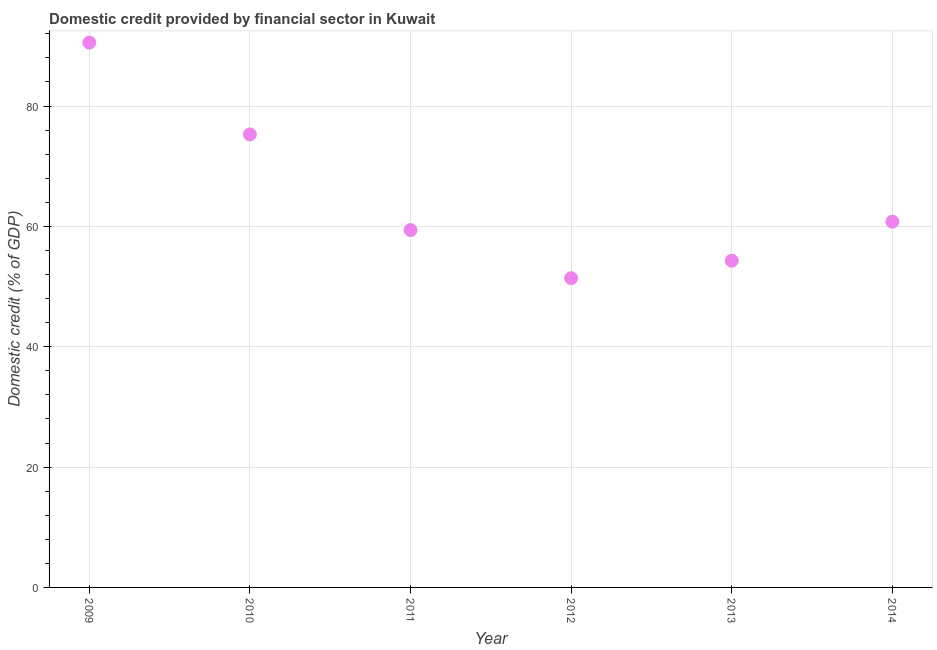What is the domestic credit provided by financial sector in 2011?
Your answer should be compact. 59.39. Across all years, what is the maximum domestic credit provided by financial sector?
Your answer should be very brief. 90.54. Across all years, what is the minimum domestic credit provided by financial sector?
Give a very brief answer. 51.39. In which year was the domestic credit provided by financial sector minimum?
Make the answer very short. 2012. What is the sum of the domestic credit provided by financial sector?
Offer a very short reply. 391.68. What is the difference between the domestic credit provided by financial sector in 2010 and 2014?
Provide a short and direct response. 14.51. What is the average domestic credit provided by financial sector per year?
Provide a short and direct response. 65.28. What is the median domestic credit provided by financial sector?
Offer a terse response. 60.08. Do a majority of the years between 2012 and 2014 (inclusive) have domestic credit provided by financial sector greater than 24 %?
Your answer should be very brief. Yes. What is the ratio of the domestic credit provided by financial sector in 2009 to that in 2013?
Your answer should be compact. 1.67. Is the domestic credit provided by financial sector in 2011 less than that in 2012?
Your answer should be very brief. No. What is the difference between the highest and the second highest domestic credit provided by financial sector?
Offer a terse response. 15.26. Is the sum of the domestic credit provided by financial sector in 2010 and 2014 greater than the maximum domestic credit provided by financial sector across all years?
Keep it short and to the point. Yes. What is the difference between the highest and the lowest domestic credit provided by financial sector?
Make the answer very short. 39.15. In how many years, is the domestic credit provided by financial sector greater than the average domestic credit provided by financial sector taken over all years?
Ensure brevity in your answer.  2. How many dotlines are there?
Make the answer very short. 1. How many years are there in the graph?
Your response must be concise. 6. What is the difference between two consecutive major ticks on the Y-axis?
Make the answer very short. 20. Are the values on the major ticks of Y-axis written in scientific E-notation?
Provide a succinct answer. No. What is the title of the graph?
Offer a very short reply. Domestic credit provided by financial sector in Kuwait. What is the label or title of the Y-axis?
Provide a succinct answer. Domestic credit (% of GDP). What is the Domestic credit (% of GDP) in 2009?
Offer a very short reply. 90.54. What is the Domestic credit (% of GDP) in 2010?
Give a very brief answer. 75.28. What is the Domestic credit (% of GDP) in 2011?
Your response must be concise. 59.39. What is the Domestic credit (% of GDP) in 2012?
Keep it short and to the point. 51.39. What is the Domestic credit (% of GDP) in 2013?
Offer a terse response. 54.3. What is the Domestic credit (% of GDP) in 2014?
Your answer should be very brief. 60.78. What is the difference between the Domestic credit (% of GDP) in 2009 and 2010?
Provide a succinct answer. 15.26. What is the difference between the Domestic credit (% of GDP) in 2009 and 2011?
Give a very brief answer. 31.15. What is the difference between the Domestic credit (% of GDP) in 2009 and 2012?
Keep it short and to the point. 39.15. What is the difference between the Domestic credit (% of GDP) in 2009 and 2013?
Offer a very short reply. 36.24. What is the difference between the Domestic credit (% of GDP) in 2009 and 2014?
Your response must be concise. 29.76. What is the difference between the Domestic credit (% of GDP) in 2010 and 2011?
Provide a short and direct response. 15.9. What is the difference between the Domestic credit (% of GDP) in 2010 and 2012?
Your answer should be very brief. 23.9. What is the difference between the Domestic credit (% of GDP) in 2010 and 2013?
Provide a succinct answer. 20.98. What is the difference between the Domestic credit (% of GDP) in 2010 and 2014?
Offer a very short reply. 14.51. What is the difference between the Domestic credit (% of GDP) in 2011 and 2012?
Provide a succinct answer. 8. What is the difference between the Domestic credit (% of GDP) in 2011 and 2013?
Provide a succinct answer. 5.09. What is the difference between the Domestic credit (% of GDP) in 2011 and 2014?
Provide a short and direct response. -1.39. What is the difference between the Domestic credit (% of GDP) in 2012 and 2013?
Give a very brief answer. -2.91. What is the difference between the Domestic credit (% of GDP) in 2012 and 2014?
Your answer should be very brief. -9.39. What is the difference between the Domestic credit (% of GDP) in 2013 and 2014?
Ensure brevity in your answer.  -6.48. What is the ratio of the Domestic credit (% of GDP) in 2009 to that in 2010?
Your answer should be compact. 1.2. What is the ratio of the Domestic credit (% of GDP) in 2009 to that in 2011?
Ensure brevity in your answer.  1.52. What is the ratio of the Domestic credit (% of GDP) in 2009 to that in 2012?
Ensure brevity in your answer.  1.76. What is the ratio of the Domestic credit (% of GDP) in 2009 to that in 2013?
Provide a short and direct response. 1.67. What is the ratio of the Domestic credit (% of GDP) in 2009 to that in 2014?
Your answer should be compact. 1.49. What is the ratio of the Domestic credit (% of GDP) in 2010 to that in 2011?
Offer a very short reply. 1.27. What is the ratio of the Domestic credit (% of GDP) in 2010 to that in 2012?
Keep it short and to the point. 1.47. What is the ratio of the Domestic credit (% of GDP) in 2010 to that in 2013?
Your answer should be compact. 1.39. What is the ratio of the Domestic credit (% of GDP) in 2010 to that in 2014?
Ensure brevity in your answer.  1.24. What is the ratio of the Domestic credit (% of GDP) in 2011 to that in 2012?
Offer a terse response. 1.16. What is the ratio of the Domestic credit (% of GDP) in 2011 to that in 2013?
Your response must be concise. 1.09. What is the ratio of the Domestic credit (% of GDP) in 2012 to that in 2013?
Your answer should be compact. 0.95. What is the ratio of the Domestic credit (% of GDP) in 2012 to that in 2014?
Provide a succinct answer. 0.85. What is the ratio of the Domestic credit (% of GDP) in 2013 to that in 2014?
Your response must be concise. 0.89. 